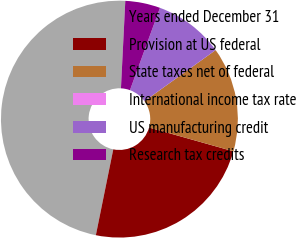Convert chart. <chart><loc_0><loc_0><loc_500><loc_500><pie_chart><fcel>Years ended December 31<fcel>Provision at US federal<fcel>State taxes net of federal<fcel>International income tax rate<fcel>US manufacturing credit<fcel>Research tax credits<nl><fcel>47.61%<fcel>23.81%<fcel>14.29%<fcel>0.0%<fcel>9.53%<fcel>4.77%<nl></chart> 